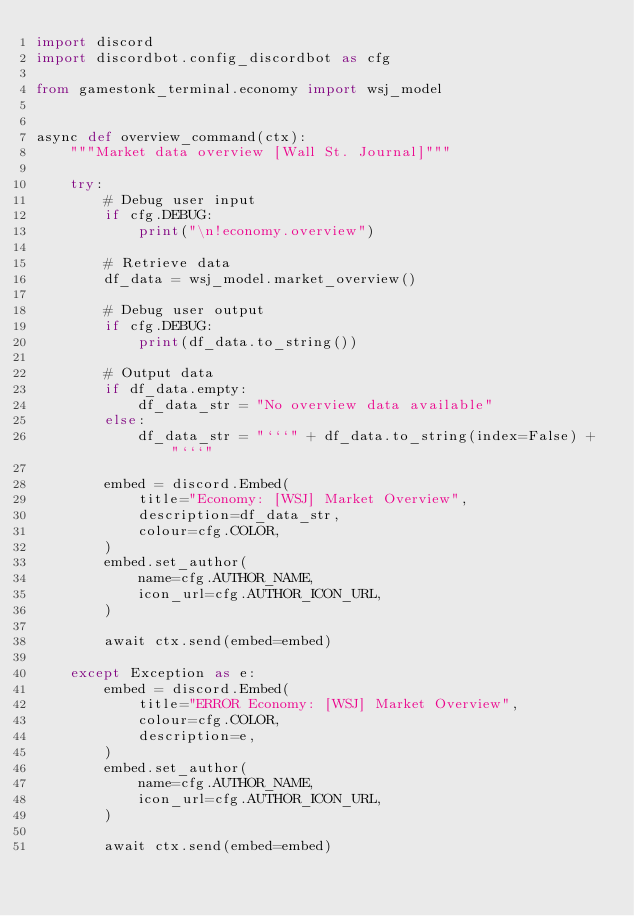<code> <loc_0><loc_0><loc_500><loc_500><_Python_>import discord
import discordbot.config_discordbot as cfg

from gamestonk_terminal.economy import wsj_model


async def overview_command(ctx):
    """Market data overview [Wall St. Journal]"""

    try:
        # Debug user input
        if cfg.DEBUG:
            print("\n!economy.overview")

        # Retrieve data
        df_data = wsj_model.market_overview()

        # Debug user output
        if cfg.DEBUG:
            print(df_data.to_string())

        # Output data
        if df_data.empty:
            df_data_str = "No overview data available"
        else:
            df_data_str = "```" + df_data.to_string(index=False) + "```"

        embed = discord.Embed(
            title="Economy: [WSJ] Market Overview",
            description=df_data_str,
            colour=cfg.COLOR,
        )
        embed.set_author(
            name=cfg.AUTHOR_NAME,
            icon_url=cfg.AUTHOR_ICON_URL,
        )

        await ctx.send(embed=embed)

    except Exception as e:
        embed = discord.Embed(
            title="ERROR Economy: [WSJ] Market Overview",
            colour=cfg.COLOR,
            description=e,
        )
        embed.set_author(
            name=cfg.AUTHOR_NAME,
            icon_url=cfg.AUTHOR_ICON_URL,
        )

        await ctx.send(embed=embed)
</code> 